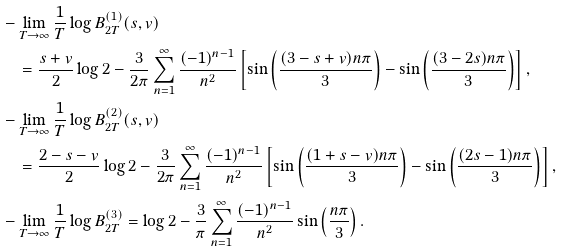Convert formula to latex. <formula><loc_0><loc_0><loc_500><loc_500>& - \lim _ { T \to \infty } \frac { 1 } { T } \log B _ { 2 T } ^ { ( 1 ) } ( s , v ) \\ & \quad = \frac { s + v } { 2 } \log 2 - \frac { 3 } { 2 \pi } \sum _ { n = 1 } ^ { \infty } \frac { ( - 1 ) ^ { n - 1 } } { n ^ { 2 } } \left [ \sin \left ( \frac { ( 3 - s + v ) n \pi } { 3 } \right ) - \sin \left ( \frac { ( 3 - 2 s ) n \pi } { 3 } \right ) \right ] , \\ & - \lim _ { T \to \infty } \frac { 1 } { T } \log B _ { 2 T } ^ { ( 2 ) } ( s , v ) \\ & \quad = \frac { 2 - s - v } { 2 } \log 2 - \frac { 3 } { 2 \pi } \sum _ { n = 1 } ^ { \infty } \frac { ( - 1 ) ^ { n - 1 } } { n ^ { 2 } } \left [ \sin \left ( \frac { ( 1 + s - v ) n \pi } { 3 } \right ) - \sin \left ( \frac { ( 2 s - 1 ) n \pi } { 3 } \right ) \right ] , \\ & - \lim _ { T \to \infty } \frac { 1 } { T } \log B _ { 2 T } ^ { ( 3 ) } = \log 2 - \frac { 3 } { \pi } \sum _ { n = 1 } ^ { \infty } \frac { ( - 1 ) ^ { n - 1 } } { n ^ { 2 } } \sin \left ( \frac { n \pi } { 3 } \right ) .</formula> 